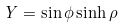Convert formula to latex. <formula><loc_0><loc_0><loc_500><loc_500>Y = \sin { \phi } \sinh { \rho }</formula> 